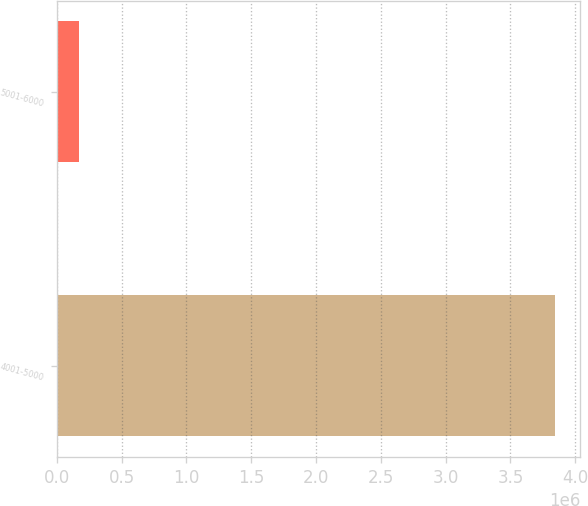<chart> <loc_0><loc_0><loc_500><loc_500><bar_chart><fcel>4001-5000<fcel>5001-6000<nl><fcel>3.84444e+06<fcel>169575<nl></chart> 